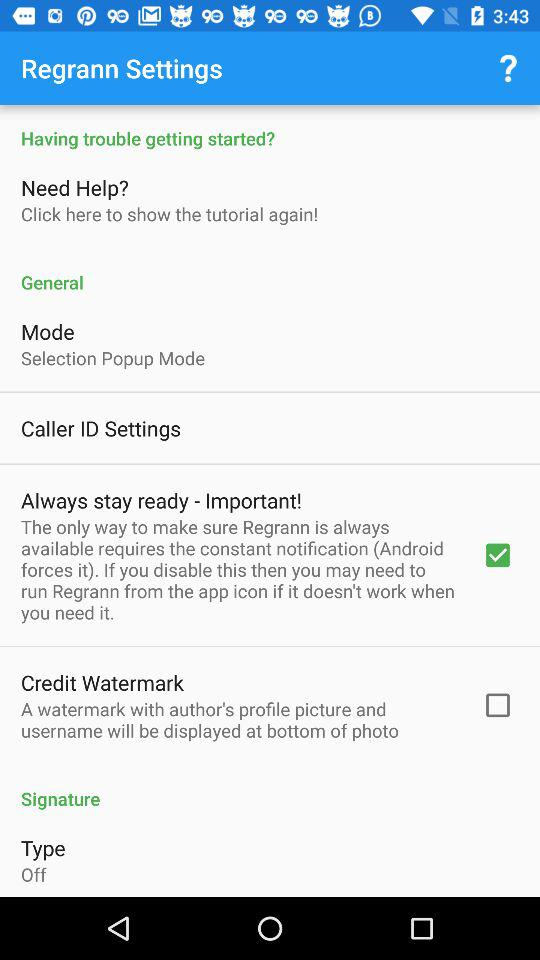What is the status of "Credit Watermark"? The status is "off". 